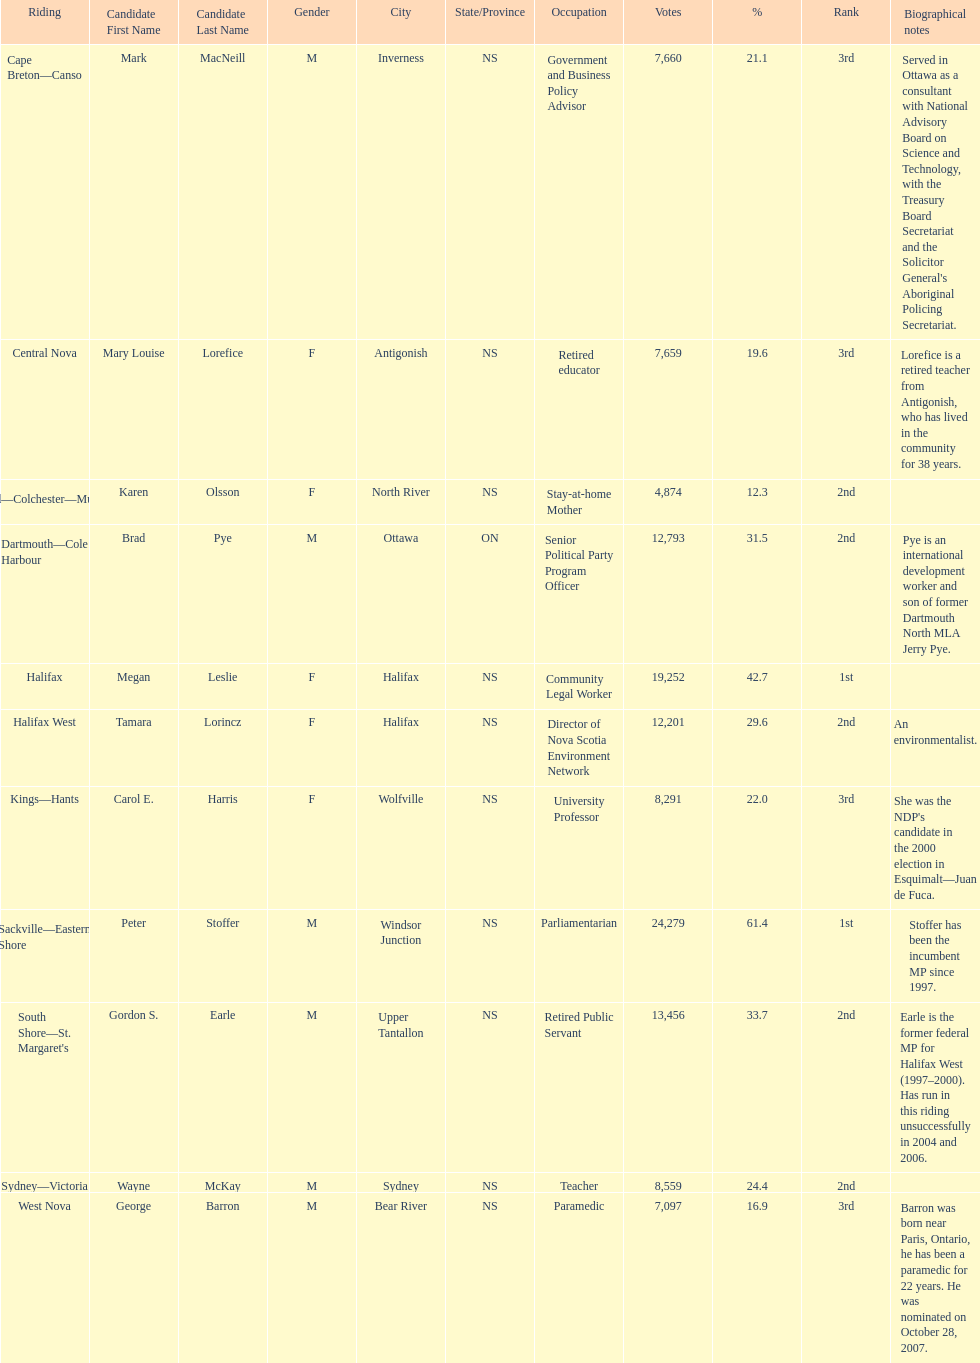What is the total number of candidates? 11. 